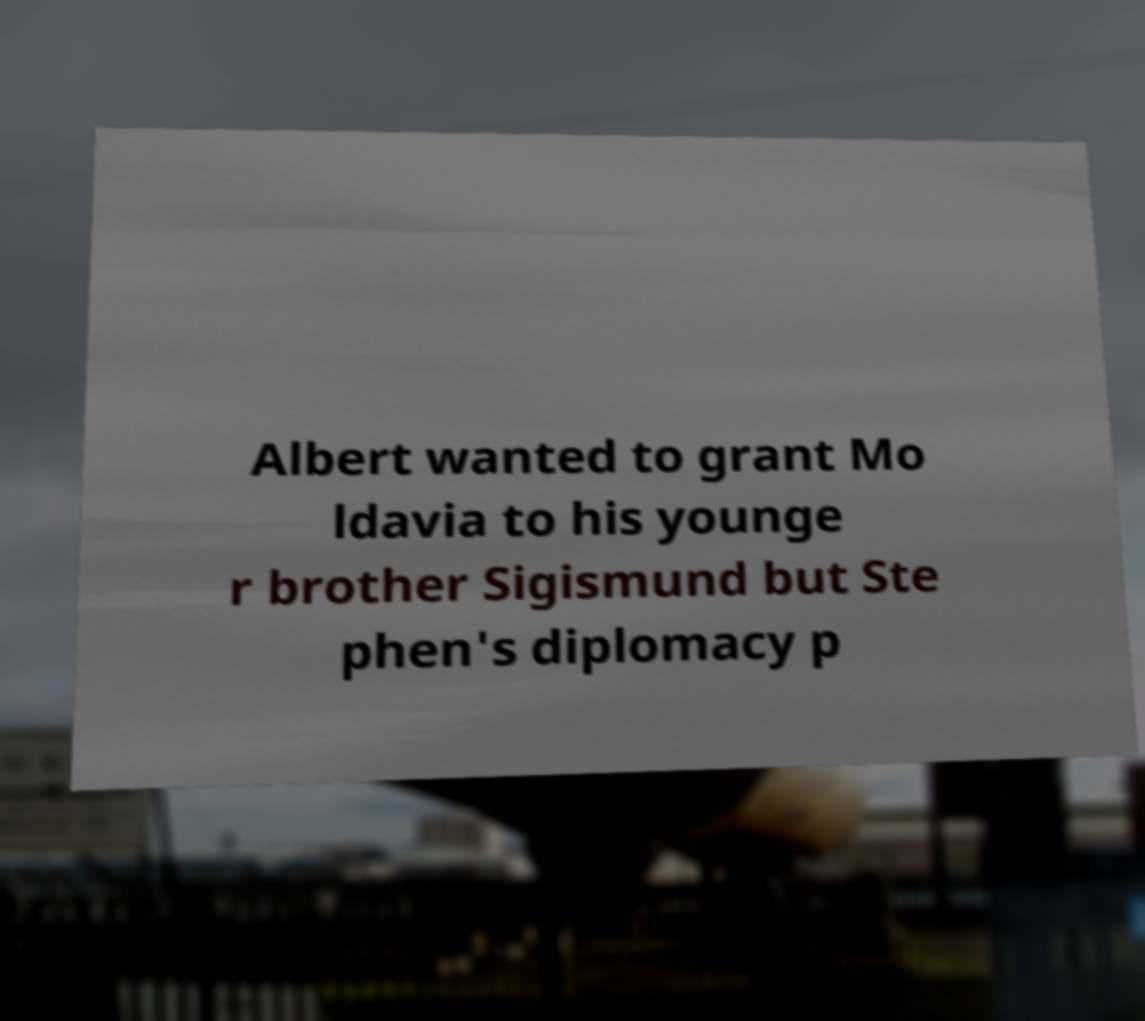I need the written content from this picture converted into text. Can you do that? Albert wanted to grant Mo ldavia to his younge r brother Sigismund but Ste phen's diplomacy p 